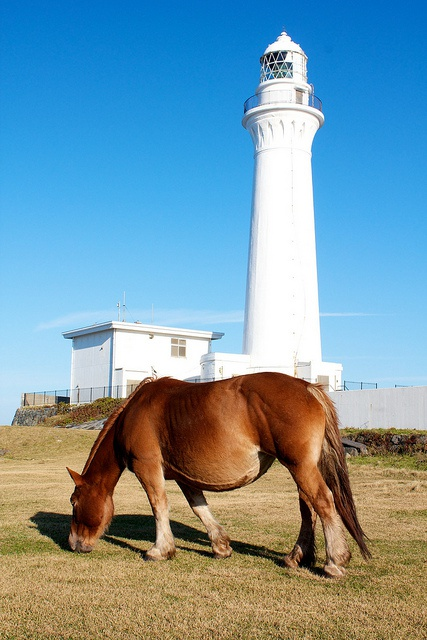Describe the objects in this image and their specific colors. I can see a horse in gray, maroon, black, brown, and tan tones in this image. 